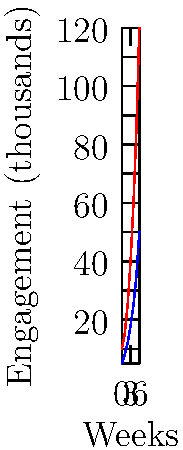Based on the social media engagement graphs for two mental health awareness campaigns over a 6-week period, which campaign shows a higher rate of growth in engagement, and what does this suggest about its effectiveness? To determine which campaign shows a higher rate of growth in engagement, we need to analyze the slopes of both lines:

1. Calculate the overall growth rate for each campaign:
   Campaign A: $(120,000 - 10,000) / 6 \text{ weeks} = 18,333$ engagements/week
   Campaign B: $(50,000 - 5,000) / 6 \text{ weeks} = 7,500$ engagements/week

2. Compare the slopes:
   Campaign A has a steeper slope, indicating a higher rate of growth.

3. Analyze the shape of the curves:
   Both curves show exponential growth, but Campaign A's curve is more pronounced.

4. Consider the final engagement numbers:
   Campaign A reaches 120,000 engagements, while Campaign B reaches 50,000.

5. Interpret the results:
   Campaign A shows a higher rate of growth and reaches a larger audience, suggesting it is more effective at spreading mental health awareness.

6. Factors to consider:
   - Initial audience size
   - Content quality and relevance
   - Targeting and distribution strategies
   - External factors affecting engagement

The higher growth rate and larger reach of Campaign A suggest it is more effective at engaging the audience and spreading mental health awareness.
Answer: Campaign A; higher growth rate and larger reach indicate greater effectiveness. 